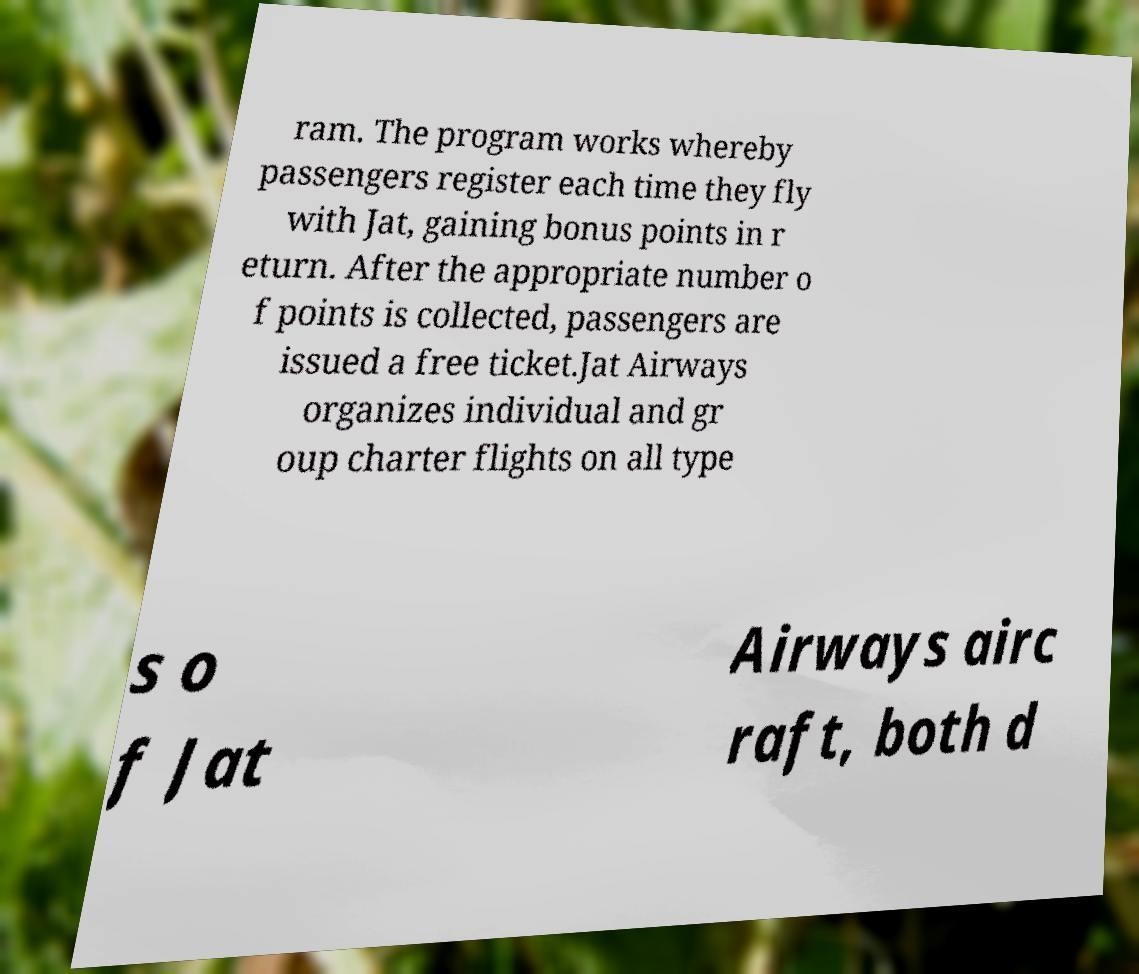What messages or text are displayed in this image? I need them in a readable, typed format. ram. The program works whereby passengers register each time they fly with Jat, gaining bonus points in r eturn. After the appropriate number o f points is collected, passengers are issued a free ticket.Jat Airways organizes individual and gr oup charter flights on all type s o f Jat Airways airc raft, both d 